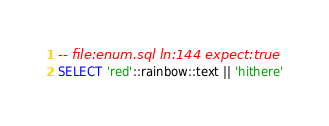Convert code to text. <code><loc_0><loc_0><loc_500><loc_500><_SQL_>-- file:enum.sql ln:144 expect:true
SELECT 'red'::rainbow::text || 'hithere'
</code> 